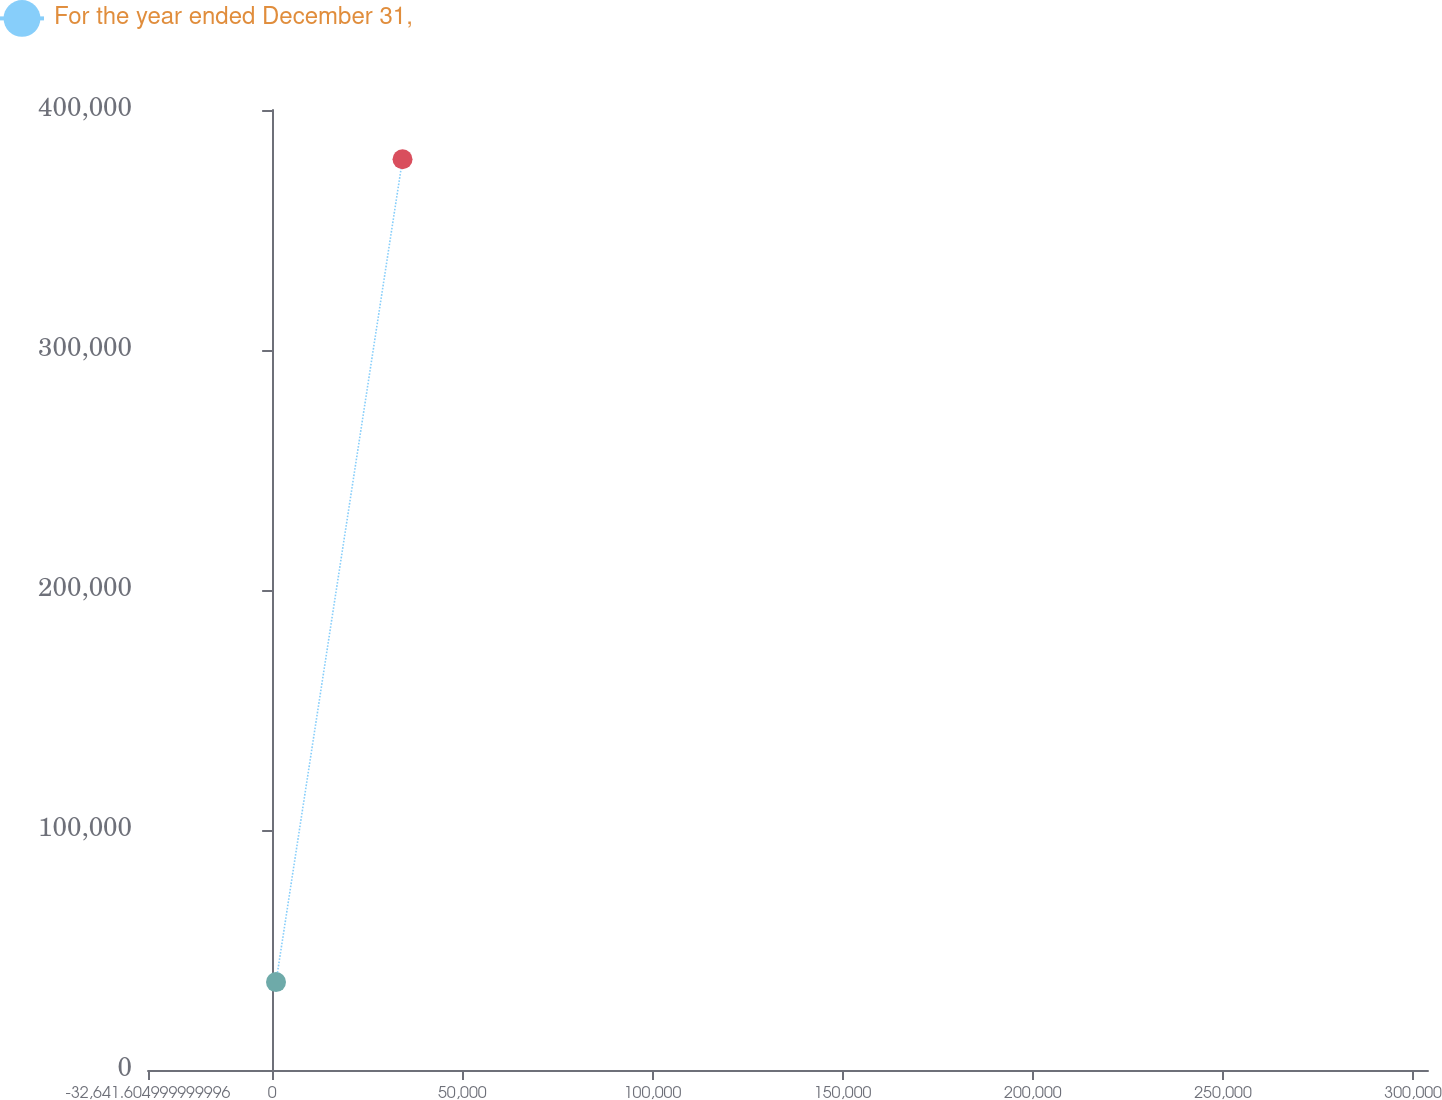Convert chart to OTSL. <chart><loc_0><loc_0><loc_500><loc_500><line_chart><ecel><fcel>For the year ended December 31,<nl><fcel>1012.58<fcel>36619.7<nl><fcel>34280.9<fcel>379458<nl><fcel>304286<fcel>342939<nl><fcel>337554<fcel>101.2<nl></chart> 